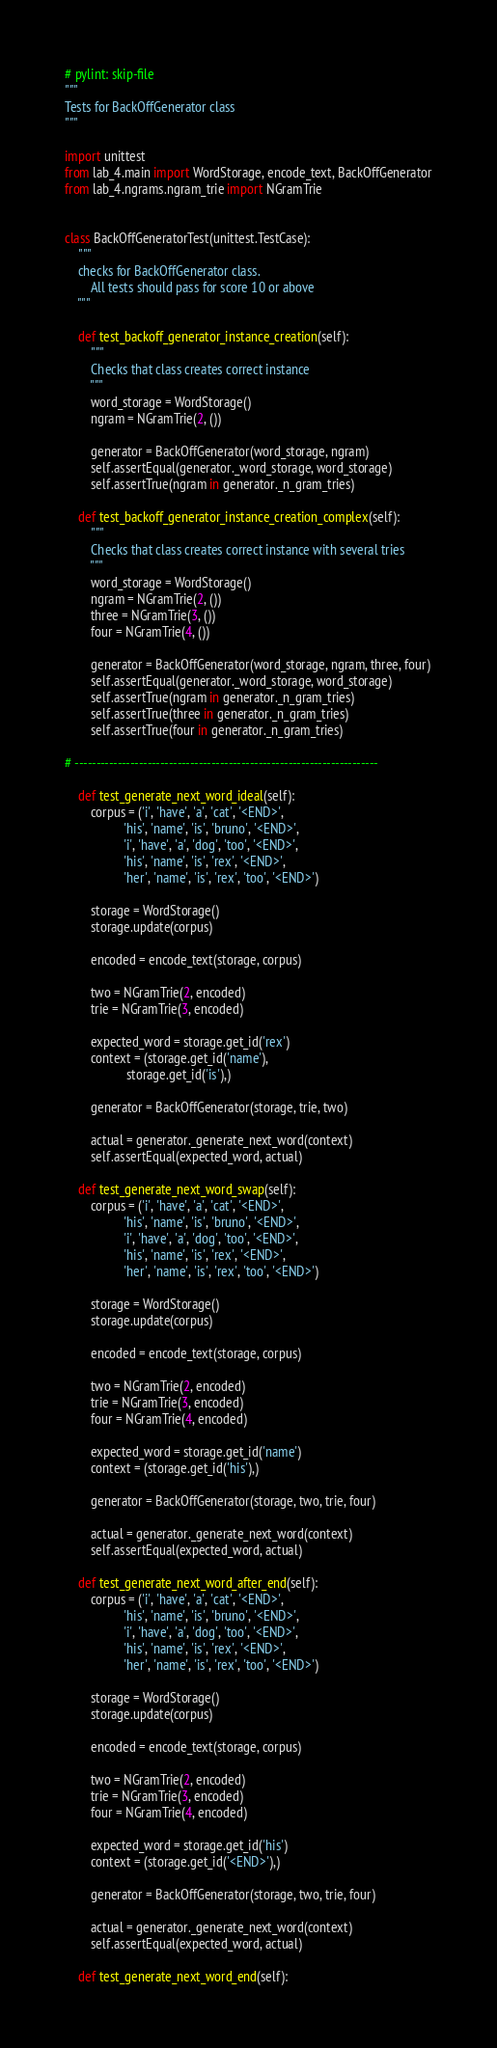Convert code to text. <code><loc_0><loc_0><loc_500><loc_500><_Python_># pylint: skip-file
"""
Tests for BackOffGenerator class
"""

import unittest
from lab_4.main import WordStorage, encode_text, BackOffGenerator
from lab_4.ngrams.ngram_trie import NGramTrie


class BackOffGeneratorTest(unittest.TestCase):
    """
    checks for BackOffGenerator class.
        All tests should pass for score 10 or above
    """

    def test_backoff_generator_instance_creation(self):
        """
        Checks that class creates correct instance
        """
        word_storage = WordStorage()
        ngram = NGramTrie(2, ())

        generator = BackOffGenerator(word_storage, ngram)
        self.assertEqual(generator._word_storage, word_storage)
        self.assertTrue(ngram in generator._n_gram_tries)

    def test_backoff_generator_instance_creation_complex(self):
        """
        Checks that class creates correct instance with several tries
        """
        word_storage = WordStorage()
        ngram = NGramTrie(2, ())
        three = NGramTrie(3, ())
        four = NGramTrie(4, ())

        generator = BackOffGenerator(word_storage, ngram, three, four)
        self.assertEqual(generator._word_storage, word_storage)
        self.assertTrue(ngram in generator._n_gram_tries)
        self.assertTrue(three in generator._n_gram_tries)
        self.assertTrue(four in generator._n_gram_tries)

# -----------------------------------------------------------------------

    def test_generate_next_word_ideal(self):
        corpus = ('i', 'have', 'a', 'cat', '<END>',
                  'his', 'name', 'is', 'bruno', '<END>',
                  'i', 'have', 'a', 'dog', 'too', '<END>',
                  'his', 'name', 'is', 'rex', '<END>',
                  'her', 'name', 'is', 'rex', 'too', '<END>')

        storage = WordStorage()
        storage.update(corpus)

        encoded = encode_text(storage, corpus)

        two = NGramTrie(2, encoded)
        trie = NGramTrie(3, encoded)

        expected_word = storage.get_id('rex')
        context = (storage.get_id('name'),
                   storage.get_id('is'),)

        generator = BackOffGenerator(storage, trie, two)

        actual = generator._generate_next_word(context)
        self.assertEqual(expected_word, actual)

    def test_generate_next_word_swap(self):
        corpus = ('i', 'have', 'a', 'cat', '<END>',
                  'his', 'name', 'is', 'bruno', '<END>',
                  'i', 'have', 'a', 'dog', 'too', '<END>',
                  'his', 'name', 'is', 'rex', '<END>',
                  'her', 'name', 'is', 'rex', 'too', '<END>')

        storage = WordStorage()
        storage.update(corpus)

        encoded = encode_text(storage, corpus)

        two = NGramTrie(2, encoded)
        trie = NGramTrie(3, encoded)
        four = NGramTrie(4, encoded)

        expected_word = storage.get_id('name')
        context = (storage.get_id('his'),)

        generator = BackOffGenerator(storage, two, trie, four)

        actual = generator._generate_next_word(context)
        self.assertEqual(expected_word, actual)

    def test_generate_next_word_after_end(self):
        corpus = ('i', 'have', 'a', 'cat', '<END>',
                  'his', 'name', 'is', 'bruno', '<END>',
                  'i', 'have', 'a', 'dog', 'too', '<END>',
                  'his', 'name', 'is', 'rex', '<END>',
                  'her', 'name', 'is', 'rex', 'too', '<END>')

        storage = WordStorage()
        storage.update(corpus)

        encoded = encode_text(storage, corpus)

        two = NGramTrie(2, encoded)
        trie = NGramTrie(3, encoded)
        four = NGramTrie(4, encoded)

        expected_word = storage.get_id('his')
        context = (storage.get_id('<END>'),)

        generator = BackOffGenerator(storage, two, trie, four)

        actual = generator._generate_next_word(context)
        self.assertEqual(expected_word, actual)

    def test_generate_next_word_end(self):</code> 